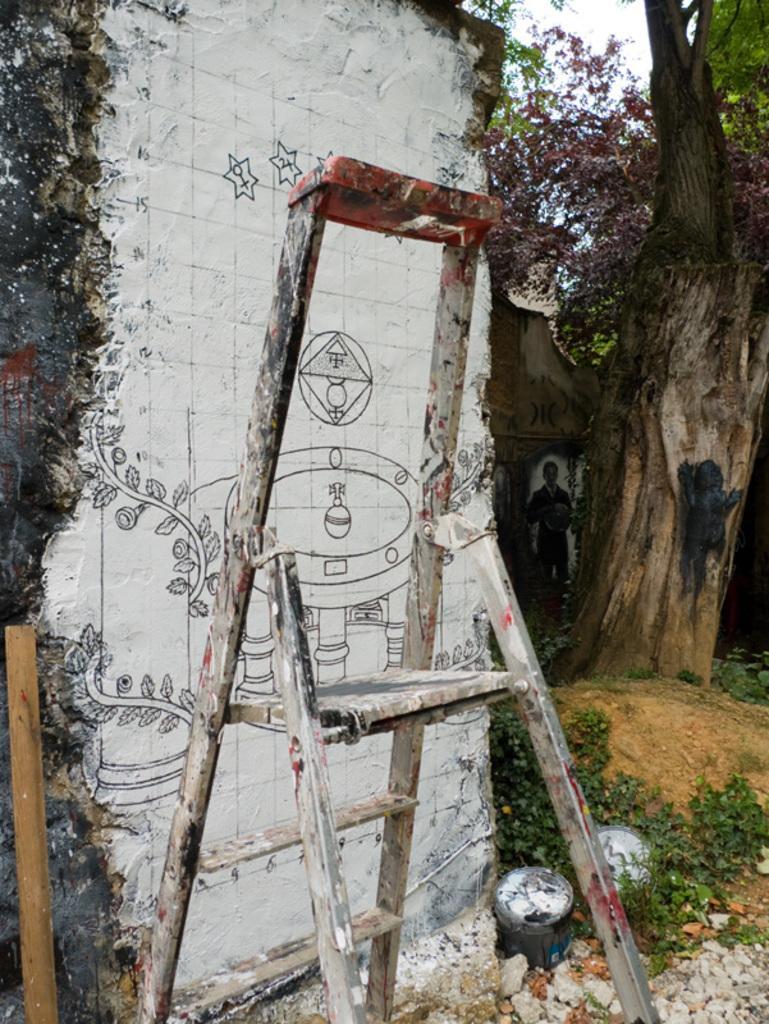Please provide a concise description of this image. In this image we can see a ladder. In the background there is a wall and we can see painting on the wall. There are trees and we can see the sky. 